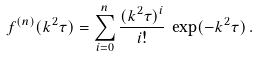Convert formula to latex. <formula><loc_0><loc_0><loc_500><loc_500>f ^ { ( n ) } ( k ^ { 2 } \tau ) = \sum _ { i = 0 } ^ { n } \frac { ( k ^ { 2 } \tau ) ^ { i } } { i ! } \, \exp ( - k ^ { 2 } \tau ) \, .</formula> 